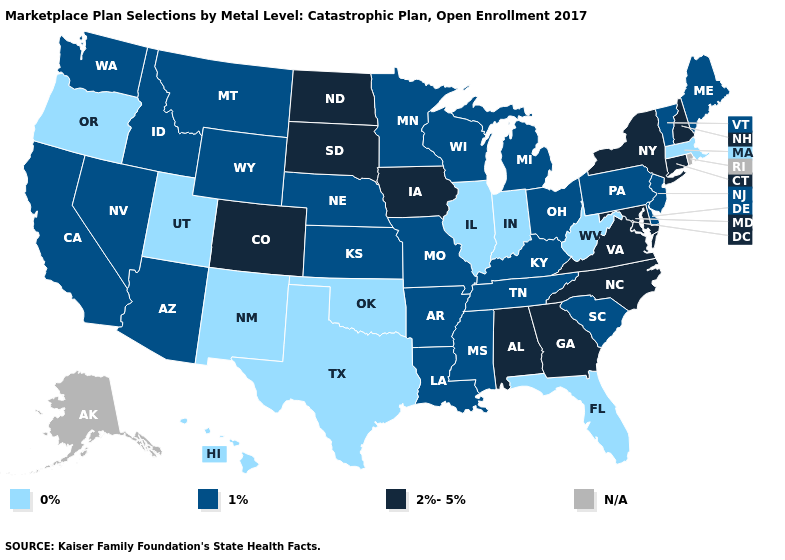Name the states that have a value in the range 2%-5%?
Concise answer only. Alabama, Colorado, Connecticut, Georgia, Iowa, Maryland, New Hampshire, New York, North Carolina, North Dakota, South Dakota, Virginia. Is the legend a continuous bar?
Answer briefly. No. Among the states that border Oregon , which have the highest value?
Write a very short answer. California, Idaho, Nevada, Washington. Among the states that border Utah , does New Mexico have the lowest value?
Be succinct. Yes. What is the lowest value in the West?
Answer briefly. 0%. Among the states that border Nebraska , which have the lowest value?
Concise answer only. Kansas, Missouri, Wyoming. What is the value of Colorado?
Be succinct. 2%-5%. What is the lowest value in states that border Nebraska?
Short answer required. 1%. Among the states that border Kansas , does Nebraska have the lowest value?
Be succinct. No. Does Vermont have the highest value in the Northeast?
Short answer required. No. What is the value of Virginia?
Write a very short answer. 2%-5%. What is the highest value in the USA?
Short answer required. 2%-5%. Name the states that have a value in the range 2%-5%?
Quick response, please. Alabama, Colorado, Connecticut, Georgia, Iowa, Maryland, New Hampshire, New York, North Carolina, North Dakota, South Dakota, Virginia. 